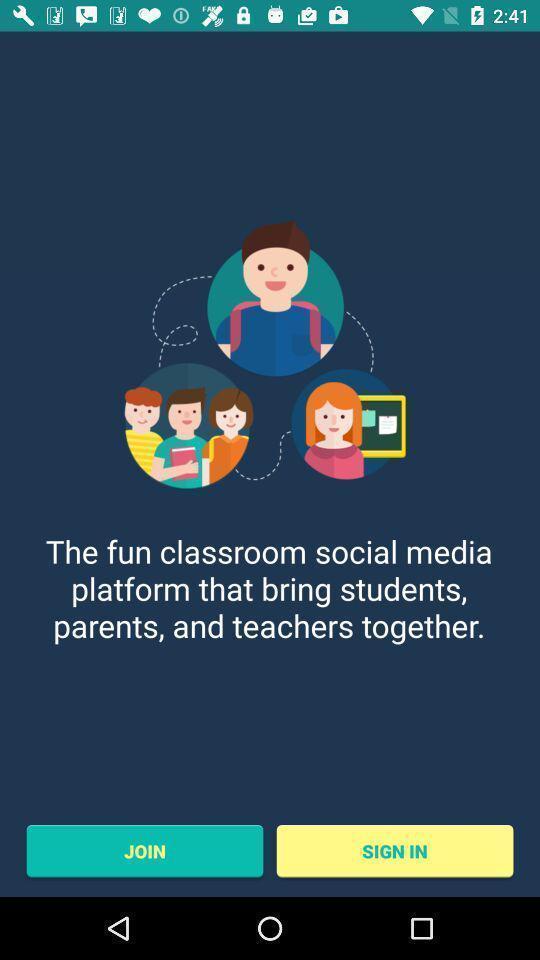Describe the key features of this screenshot. Welcome page of a learning app. 